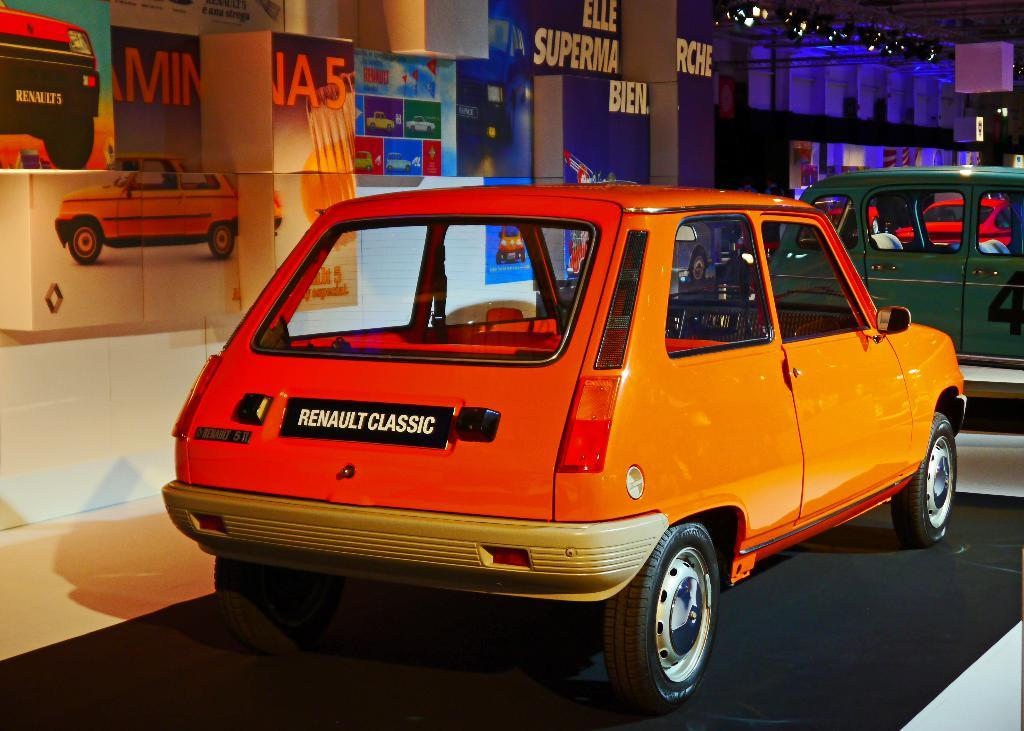What can be seen in the image? There are vehicles in the image. What is visible in the background of the image? There is a wall with images and text in the background of the image. What type of lighting is present in the image? There are focus lights in the image. How much money is being exchanged between the vehicles in the image? There is no indication of money being exchanged in the image; it only shows vehicles, a wall with images and text, and focus lights. 